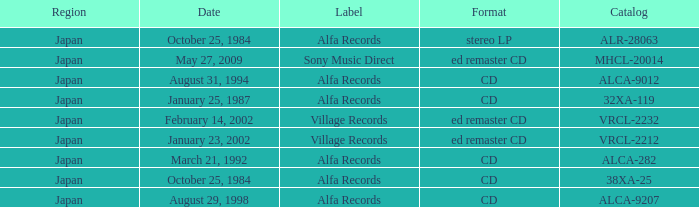What Label released on October 25, 1984, in the format of Stereo LP? Alfa Records. 